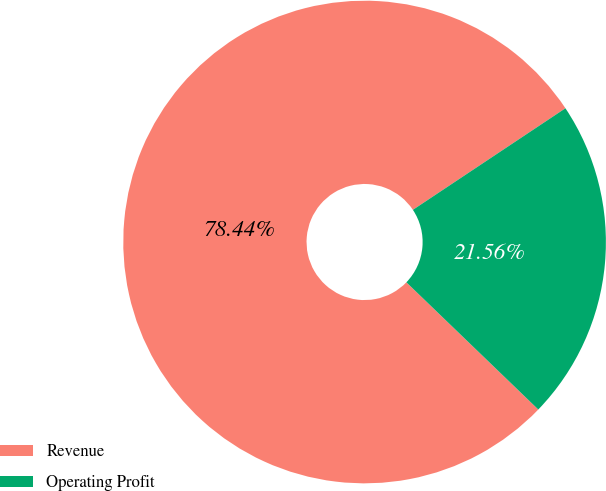<chart> <loc_0><loc_0><loc_500><loc_500><pie_chart><fcel>Revenue<fcel>Operating Profit<nl><fcel>78.44%<fcel>21.56%<nl></chart> 